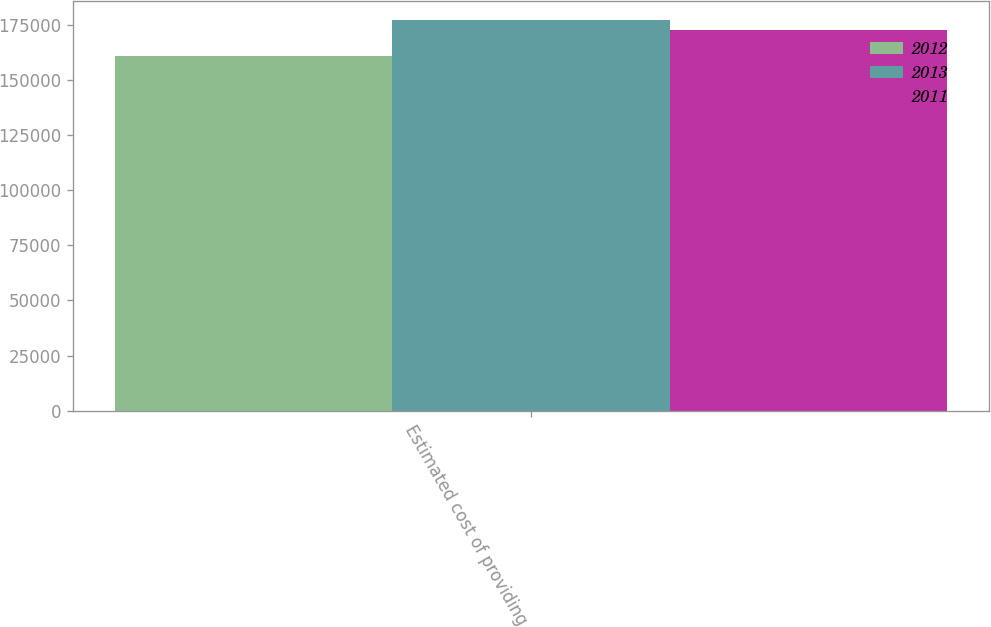Convert chart. <chart><loc_0><loc_0><loc_500><loc_500><stacked_bar_chart><ecel><fcel>Estimated cost of providing<nl><fcel>2012<fcel>161013<nl><fcel>2013<fcel>177189<nl><fcel>2011<fcel>172713<nl></chart> 